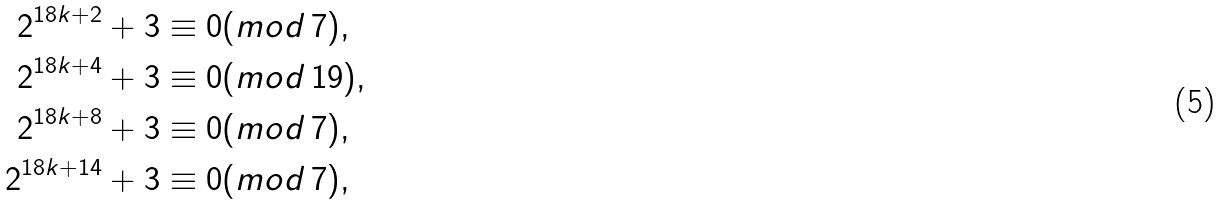Convert formula to latex. <formula><loc_0><loc_0><loc_500><loc_500>2 ^ { 1 8 k + 2 } + 3 & \equiv 0 ( m o d \, 7 ) , \\ 2 ^ { 1 8 k + 4 } + 3 & \equiv 0 ( m o d \, 1 9 ) , \\ 2 ^ { 1 8 k + 8 } + 3 & \equiv 0 ( m o d \, 7 ) , \\ 2 ^ { 1 8 k + 1 4 } + 3 & \equiv 0 ( m o d \, 7 ) , \\</formula> 